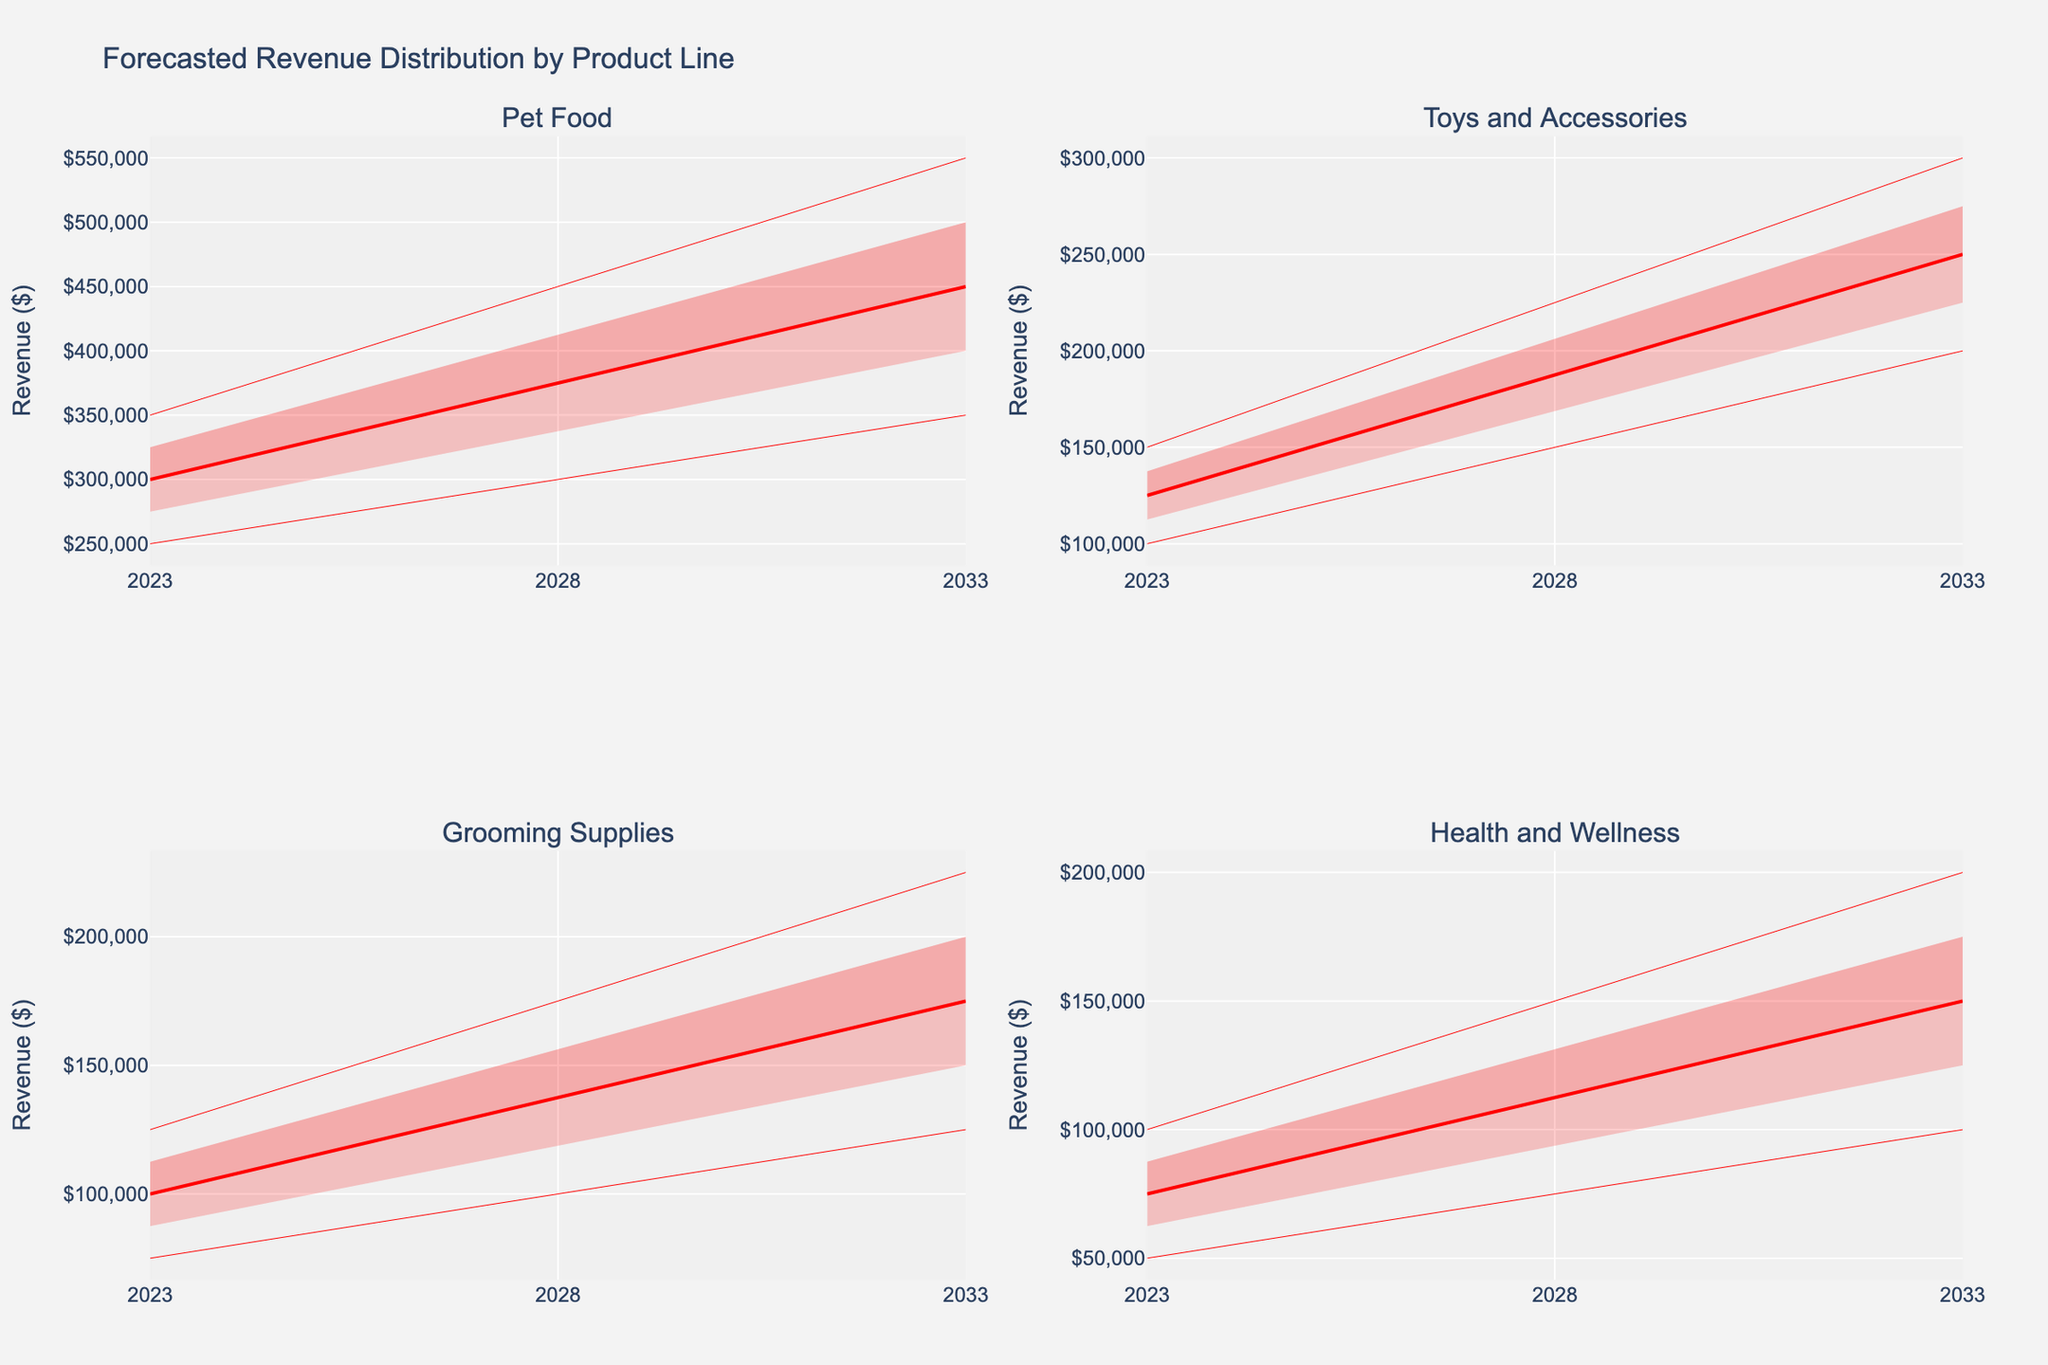What's the title of the figure? The title is usually at the top of the figure. By looking at it, you can see the main subject of the visualization.
Answer: Forecasted Revenue Distribution by Product Line How many product lines are displayed? Since there are four subplot titles corresponding to each product line, we can count them.
Answer: 4 Which product line shows the highest revenue estimate for 2033? Look for the highest point on the y-axis in 2033 across all subplots. The highest value will indicate the product line with the highest revenue.
Answer: Pet Food How does the forecasted revenue for Toys and Accessories in 2028 compare to 2023? Check the mid estimate values for Toys and Accessories in both 2023 and 2028 in its subplot and compare them.
Answer: It increases by $62,500 What is the approximate range of mid estimates for Grooming Supplies from 2023 to 2033? Observe the mid-line for Grooming Supplies subplot from 2023 to 2033 and note the lowest and highest points.
Answer: $100,000 to $175,000 In which year is the forecasted revenue range (from low to high estimates) widest for Health and Wellness? Compare the gap between the highest and lowest estimates for Health and Wellness across the years. The year with the largest gap has the widest range.
Answer: 2033 Which product line has the smallest forecasted revenue in 2023? Check the lowest point on the y-axis for 2023 across all subplots. The smallest value will indicate the product line with the smallest revenue.
Answer: Health and Wellness Compare the revenue growth between 2023 and 2033 for Pet Food and Grooming Supplies. Which one's growth is higher? Subtract the mid estimate of 2023 from 2033 for both Pet Food and Grooming Supplies and compare the differences.
Answer: Pet Food What does the red shaded area represent in the plots? The red shaded areas between the lines indicate the uncertainty or distribution range of the forecasted revenues for different confidence levels.
Answer: Forecast Uncertainty What is the mid estimate value for Health and Wellness in 2028? Locate the point on the mid-line for Health and Wellness subplot where the year is 2028.
Answer: $112,500 